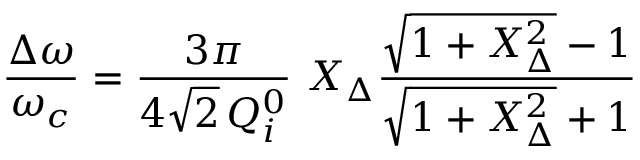<formula> <loc_0><loc_0><loc_500><loc_500>\frac { \Delta \omega } { \omega _ { c } } = \frac { 3 \pi } { 4 \sqrt { 2 } \, Q _ { i } ^ { 0 } } \ X _ { \Delta } \frac { \sqrt { 1 + X _ { \Delta } ^ { 2 } } - 1 } { \sqrt { 1 + X _ { \Delta } ^ { 2 } } + 1 }</formula> 